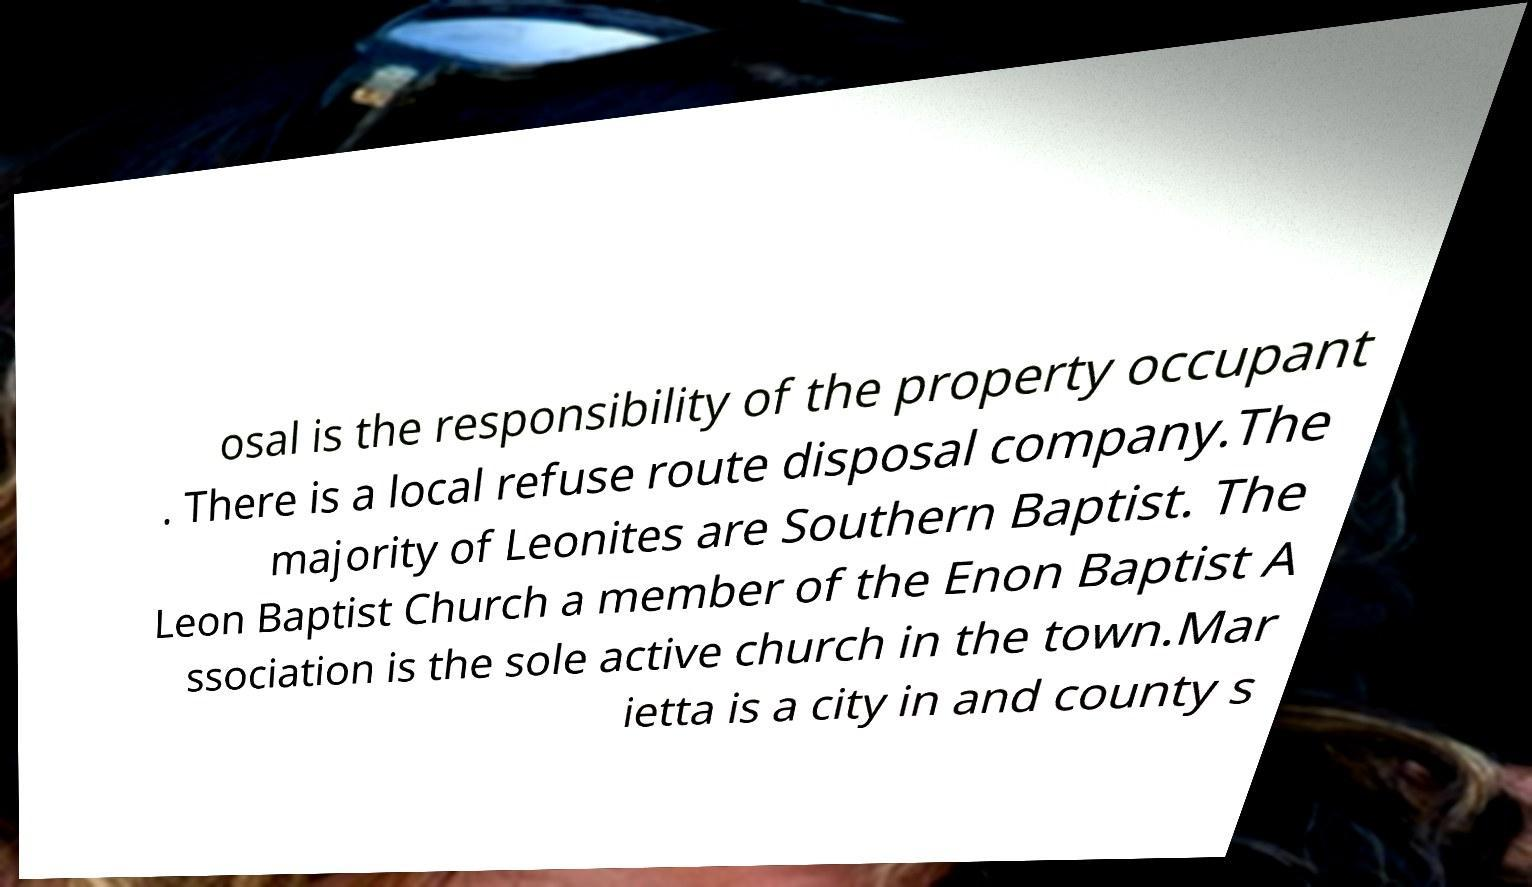Can you accurately transcribe the text from the provided image for me? osal is the responsibility of the property occupant . There is a local refuse route disposal company.The majority of Leonites are Southern Baptist. The Leon Baptist Church a member of the Enon Baptist A ssociation is the sole active church in the town.Mar ietta is a city in and county s 